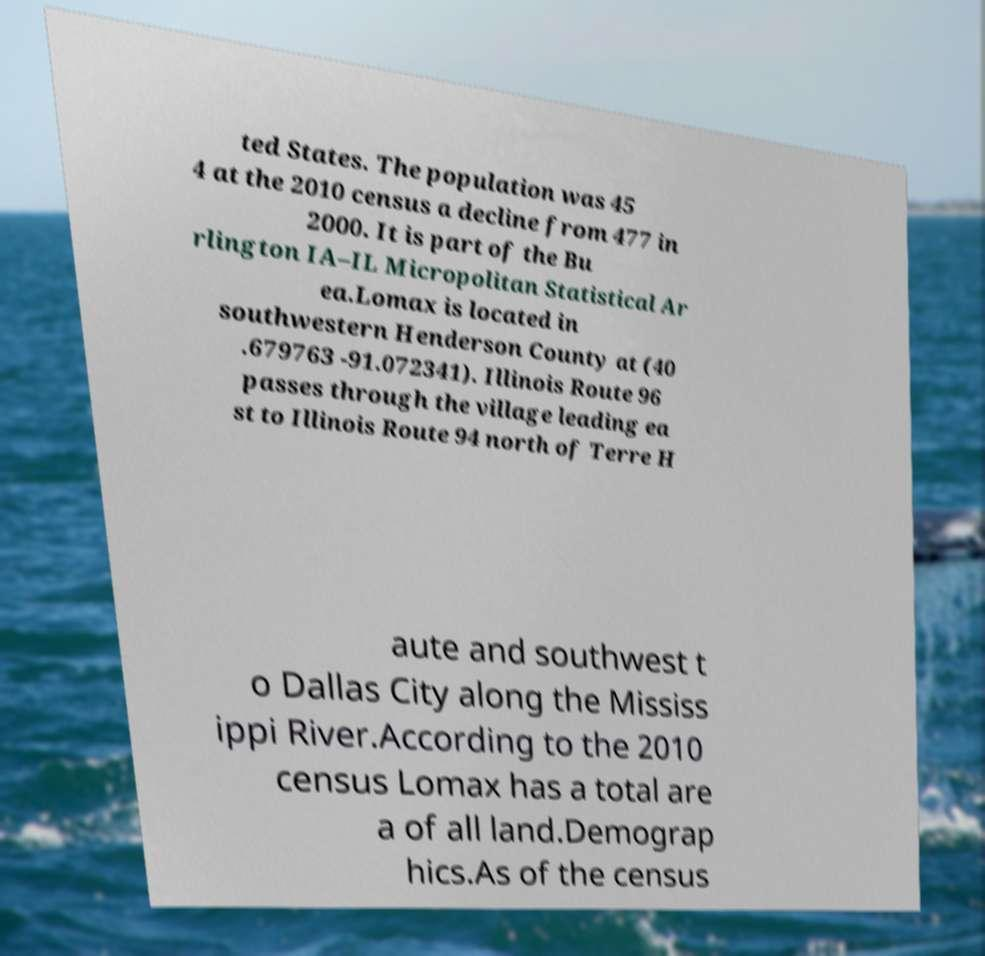Please identify and transcribe the text found in this image. ted States. The population was 45 4 at the 2010 census a decline from 477 in 2000. It is part of the Bu rlington IA–IL Micropolitan Statistical Ar ea.Lomax is located in southwestern Henderson County at (40 .679763 -91.072341). Illinois Route 96 passes through the village leading ea st to Illinois Route 94 north of Terre H aute and southwest t o Dallas City along the Mississ ippi River.According to the 2010 census Lomax has a total are a of all land.Demograp hics.As of the census 